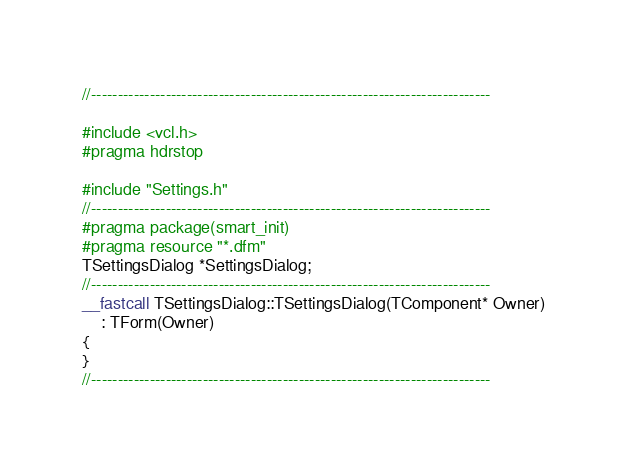Convert code to text. <code><loc_0><loc_0><loc_500><loc_500><_C++_>//---------------------------------------------------------------------------

#include <vcl.h>
#pragma hdrstop

#include "Settings.h"
//---------------------------------------------------------------------------
#pragma package(smart_init)
#pragma resource "*.dfm"
TSettingsDialog *SettingsDialog;
//---------------------------------------------------------------------------
__fastcall TSettingsDialog::TSettingsDialog(TComponent* Owner)
	: TForm(Owner)
{
}
//---------------------------------------------------------------------------
</code> 